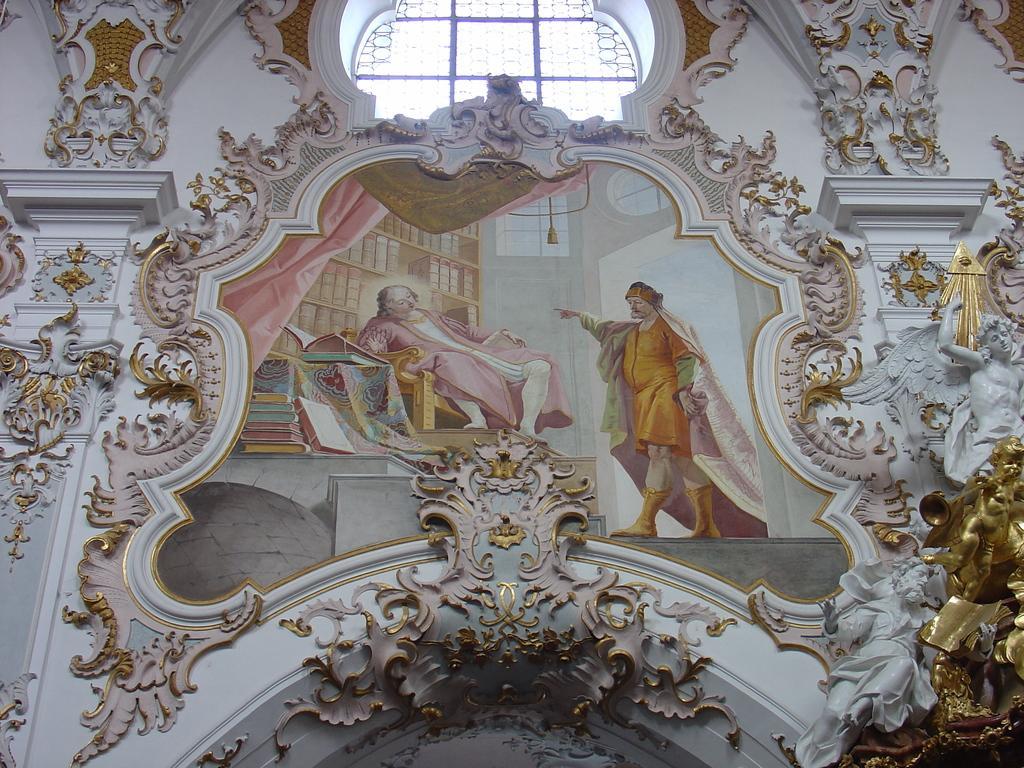Please provide a concise description of this image. In this picture there is a portrait in the center of the image and there is a glass window at the top side of the image, there are decorated sides around the portrait. 